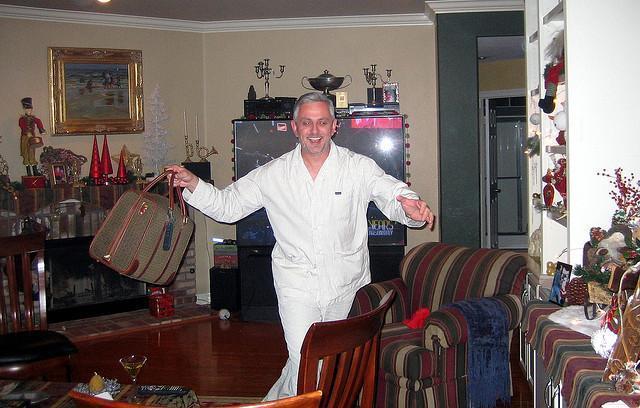How many chairs are there?
Give a very brief answer. 3. 